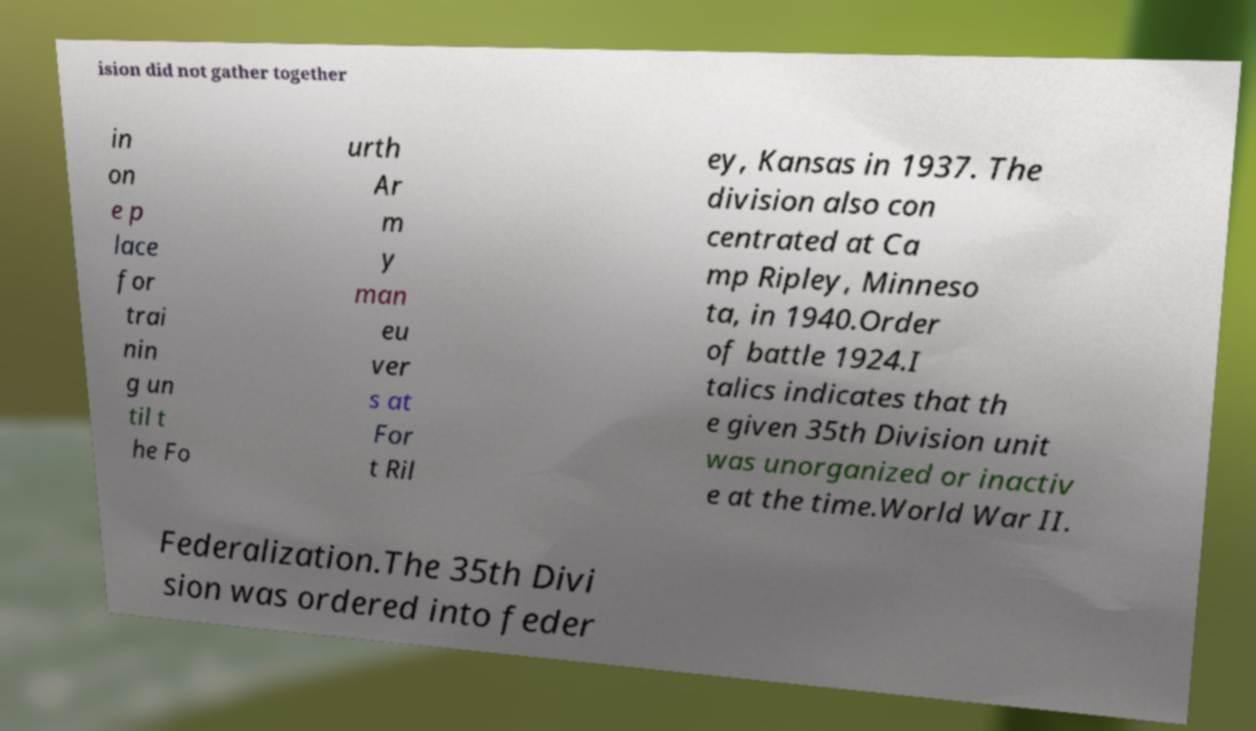Could you extract and type out the text from this image? ision did not gather together in on e p lace for trai nin g un til t he Fo urth Ar m y man eu ver s at For t Ril ey, Kansas in 1937. The division also con centrated at Ca mp Ripley, Minneso ta, in 1940.Order of battle 1924.I talics indicates that th e given 35th Division unit was unorganized or inactiv e at the time.World War II. Federalization.The 35th Divi sion was ordered into feder 